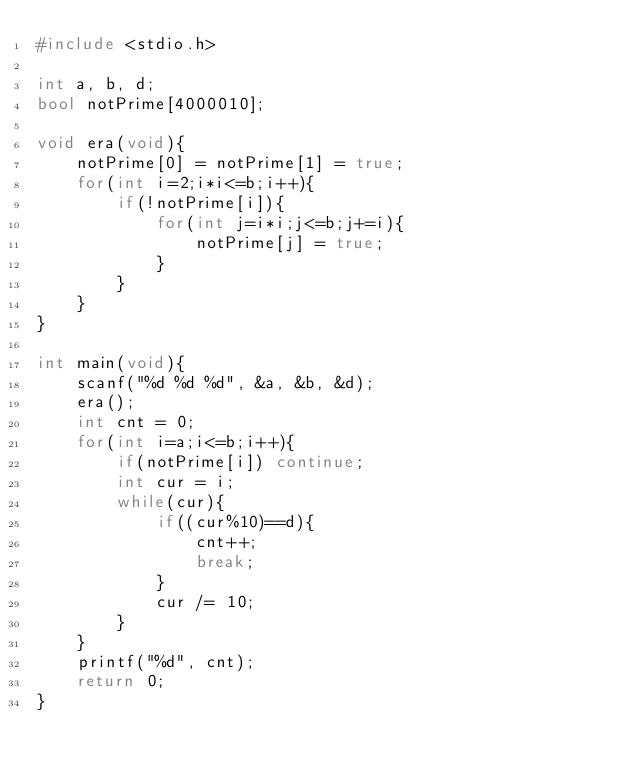<code> <loc_0><loc_0><loc_500><loc_500><_C++_>#include <stdio.h>

int a, b, d;
bool notPrime[4000010];

void era(void){
    notPrime[0] = notPrime[1] = true;
    for(int i=2;i*i<=b;i++){
        if(!notPrime[i]){
            for(int j=i*i;j<=b;j+=i){
                notPrime[j] = true;
            }
        }
    }
}

int main(void){
    scanf("%d %d %d", &a, &b, &d);
    era();
    int cnt = 0;
    for(int i=a;i<=b;i++){
        if(notPrime[i]) continue;
        int cur = i;
        while(cur){
            if((cur%10)==d){
                cnt++;
                break;
            }
            cur /= 10;
        }
    }
    printf("%d", cnt);
    return 0;
}
</code> 